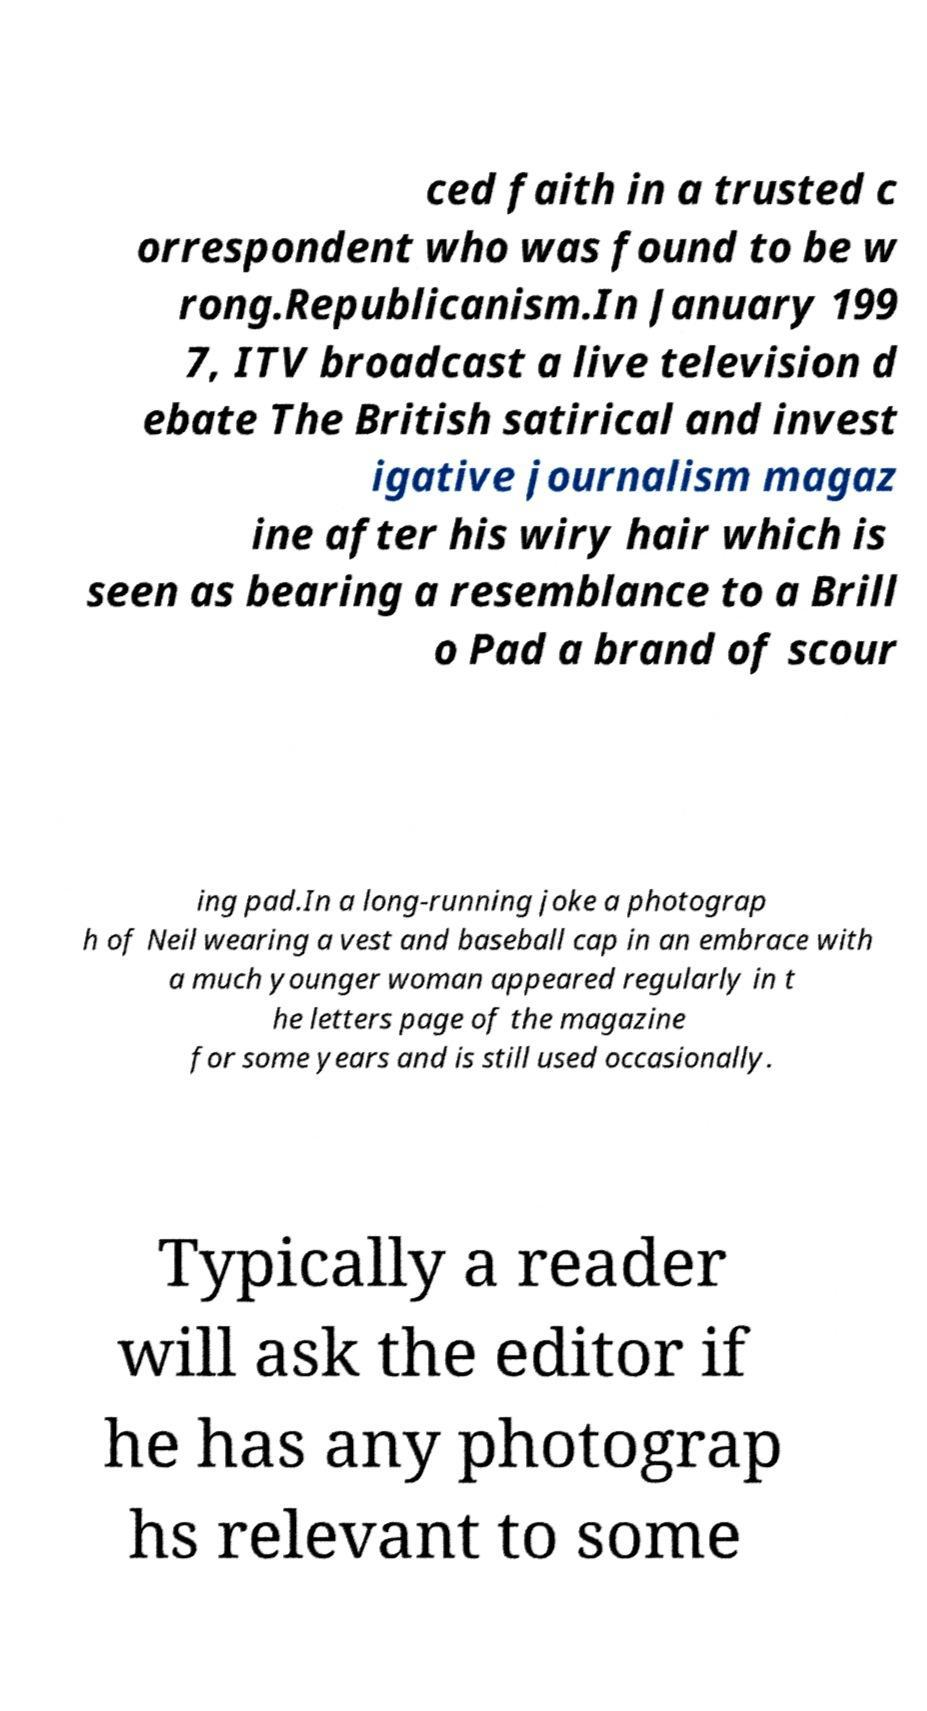Please read and relay the text visible in this image. What does it say? ced faith in a trusted c orrespondent who was found to be w rong.Republicanism.In January 199 7, ITV broadcast a live television d ebate The British satirical and invest igative journalism magaz ine after his wiry hair which is seen as bearing a resemblance to a Brill o Pad a brand of scour ing pad.In a long-running joke a photograp h of Neil wearing a vest and baseball cap in an embrace with a much younger woman appeared regularly in t he letters page of the magazine for some years and is still used occasionally. Typically a reader will ask the editor if he has any photograp hs relevant to some 